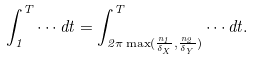<formula> <loc_0><loc_0><loc_500><loc_500>\int _ { 1 } ^ { T } \cdots d t = \int _ { 2 \pi \max ( \frac { n _ { 1 } } { \delta _ { X } } , \frac { n _ { 2 } } { \delta _ { Y } } ) } ^ { T } \cdots d t .</formula> 